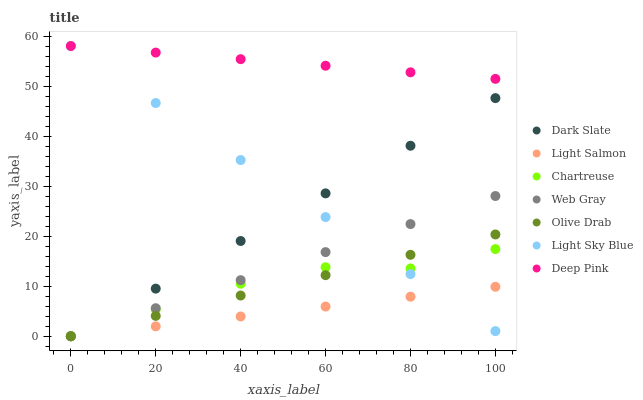Does Light Salmon have the minimum area under the curve?
Answer yes or no. Yes. Does Deep Pink have the maximum area under the curve?
Answer yes or no. Yes. Does Web Gray have the minimum area under the curve?
Answer yes or no. No. Does Web Gray have the maximum area under the curve?
Answer yes or no. No. Is Dark Slate the smoothest?
Answer yes or no. Yes. Is Chartreuse the roughest?
Answer yes or no. Yes. Is Web Gray the smoothest?
Answer yes or no. No. Is Web Gray the roughest?
Answer yes or no. No. Does Light Salmon have the lowest value?
Answer yes or no. Yes. Does Deep Pink have the lowest value?
Answer yes or no. No. Does Light Sky Blue have the highest value?
Answer yes or no. Yes. Does Web Gray have the highest value?
Answer yes or no. No. Is Light Salmon less than Deep Pink?
Answer yes or no. Yes. Is Deep Pink greater than Web Gray?
Answer yes or no. Yes. Does Dark Slate intersect Olive Drab?
Answer yes or no. Yes. Is Dark Slate less than Olive Drab?
Answer yes or no. No. Is Dark Slate greater than Olive Drab?
Answer yes or no. No. Does Light Salmon intersect Deep Pink?
Answer yes or no. No. 